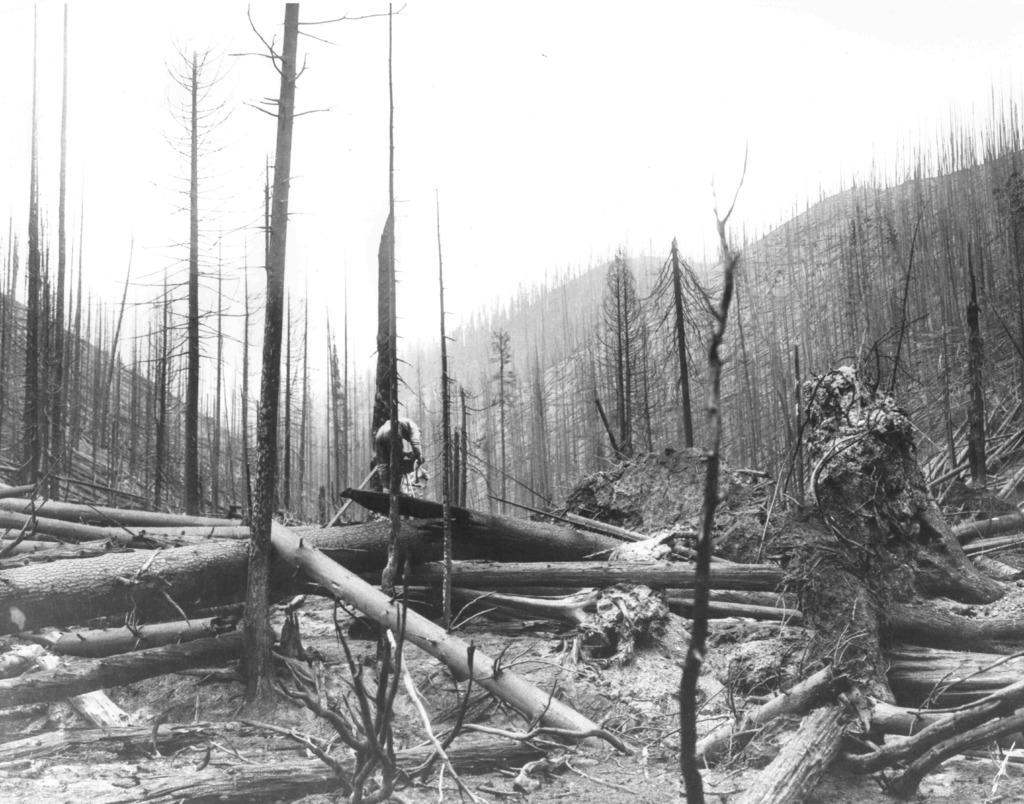What type of vegetation is present in the image? There are trees in the image. What part of the trees can be seen on the ground in the image? There are tree trunks on the ground in the image. What is the color scheme of the image? The image is black and white in color. What type of pin can be seen holding up the level in the image? There is no pin or level present in the image; it only features trees and tree trunks in a black and white color scheme. 